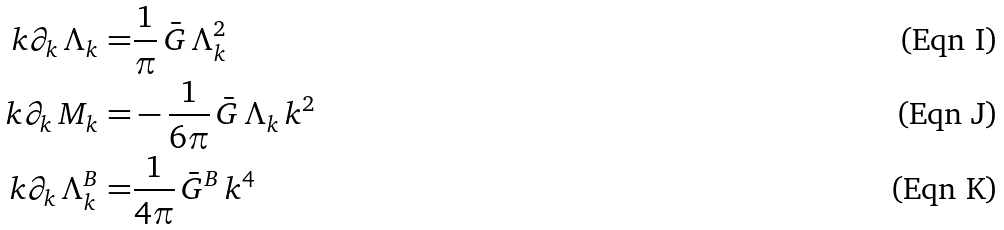<formula> <loc_0><loc_0><loc_500><loc_500>k \partial _ { k } \, \Lambda _ { k } = & \frac { 1 } { \pi } \, \bar { G } \, \Lambda _ { k } ^ { 2 } \\ k \partial _ { k } \, M _ { k } = & - \frac { 1 } { 6 \pi } \, \bar { G } \, \Lambda _ { k } \, k ^ { 2 } \\ k \partial _ { k } \, \Lambda _ { k } ^ { B } = & \frac { 1 } { 4 \pi } \, \bar { G } ^ { B } \, k ^ { 4 }</formula> 